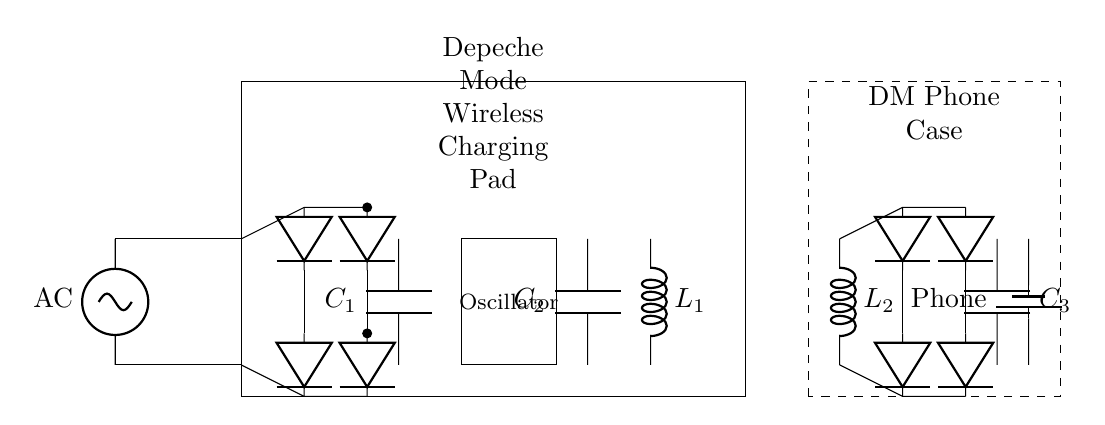What is the primary function of the wireless charging pad? The primary function of the wireless charging pad is to convert AC to DC and facilitate the wireless transfer of energy to the smartphone case. The circuit includes components that rectify AC input and create an electromagnetic field for transmission.
Answer: energy transfer What is the role of the capacitors in this circuit? The capacitors serve two main purposes: the smoothing capacitor (C1) filters the rectified DC voltage to reduce ripple, and the tuning capacitor (C2) is part of the oscillator circuit to ensure efficient energy transfer. Capacitors stabilize voltage in different parts of the circuit.
Answer: filtering and tuning What components are responsible for rectification in the circuit? The components responsible for rectification are the diodes. They convert the AC voltage to DC by allowing current to flow in one direction while blocking it in the opposite, thus ensuring proper charging of the phone battery.
Answer: diodes What type of inductor is used in the circuit? The circuit features two inductors, labeled L1 and L2. Both inductors are used to create a magnetic field for energy transfer and are integral for the operation of the wireless charging system.
Answer: inductor How many diodes are present in the rectification stage? There are a total of four diodes in the rectification stage, two near the rectifier for the charging pad and two for the receiving circuit in the phone case. Each pair forms a full bridge to convert AC to DC effectively.
Answer: four What is the load in this circuit? The load in this circuit is the smartphone battery. It draws energy from the output provided after rectification and smoothing, ultimately powering the phone.
Answer: phone battery 